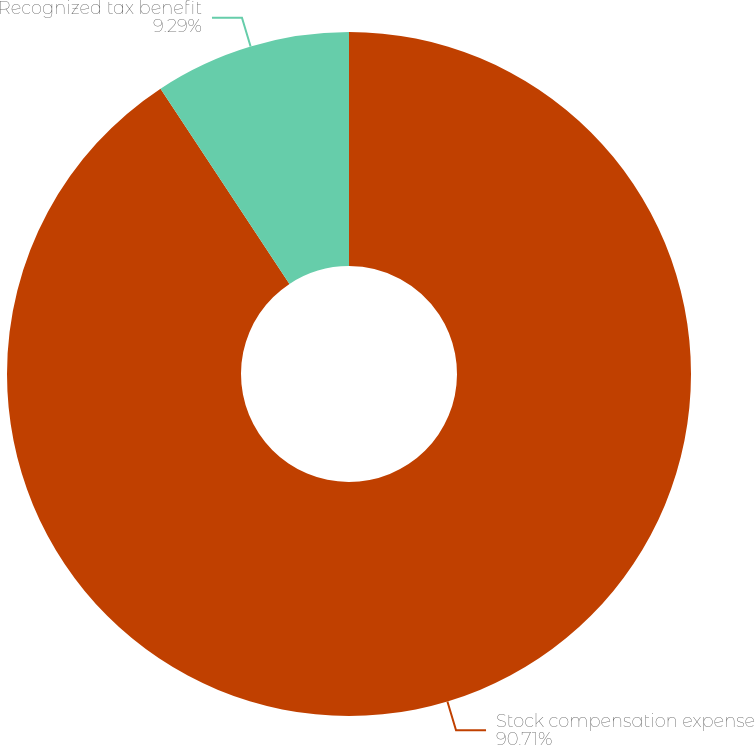Convert chart. <chart><loc_0><loc_0><loc_500><loc_500><pie_chart><fcel>Stock compensation expense<fcel>Recognized tax benefit<nl><fcel>90.71%<fcel>9.29%<nl></chart> 